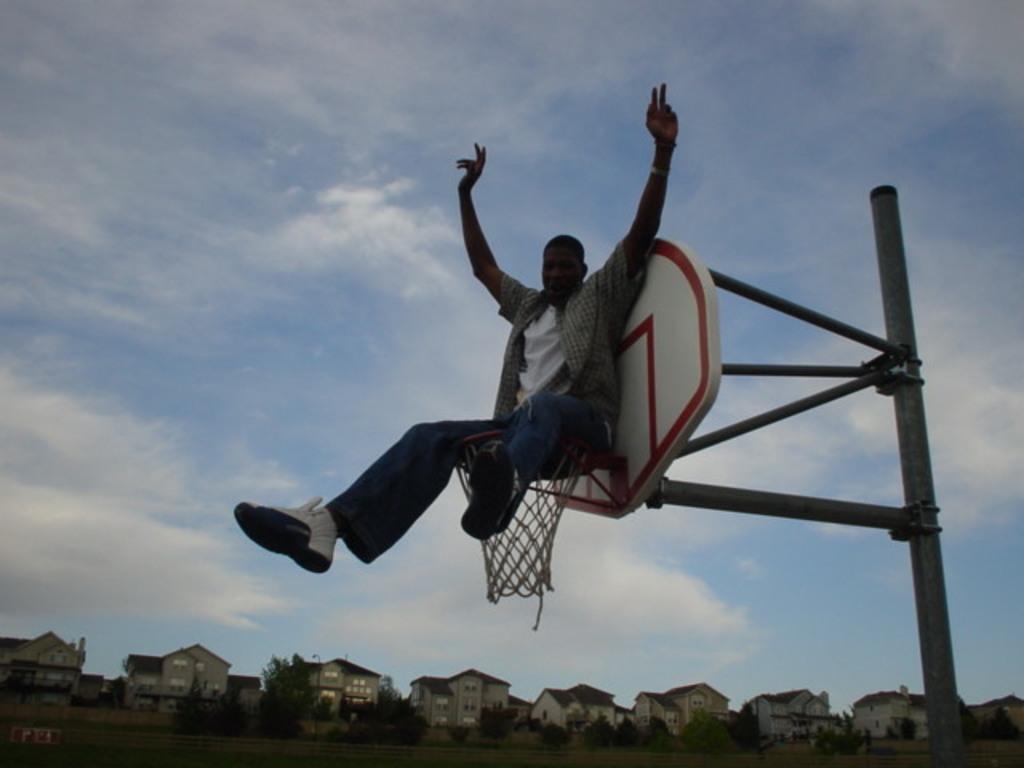How would you summarize this image in a sentence or two? In this Image I can see a person sitting on the net. Back I can see a board is attached to the pole. I can see few buildings,windows,trees,light poles. The sky is in blue and white color. 